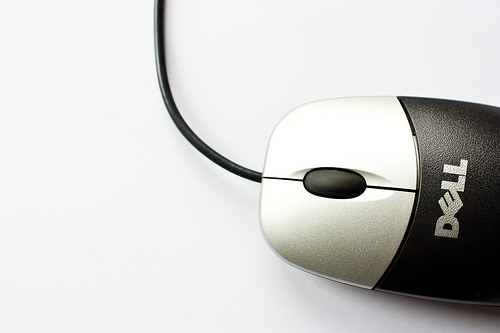<image>
Is there a wire to the left of the mouse? Yes. From this viewpoint, the wire is positioned to the left side relative to the mouse. 